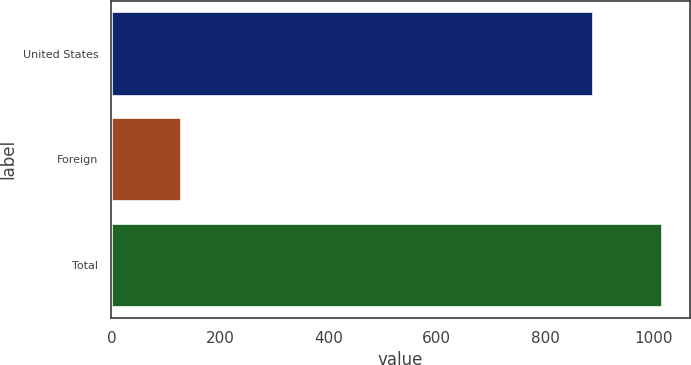<chart> <loc_0><loc_0><loc_500><loc_500><bar_chart><fcel>United States<fcel>Foreign<fcel>Total<nl><fcel>888<fcel>128<fcel>1016<nl></chart> 